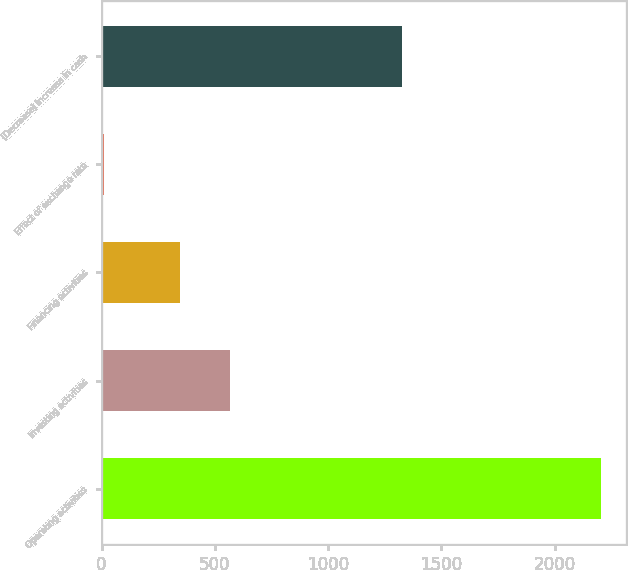Convert chart to OTSL. <chart><loc_0><loc_0><loc_500><loc_500><bar_chart><fcel>Operating activities<fcel>Investing activities<fcel>Financing activities<fcel>Effect of exchange rate<fcel>(Decrease) increase in cash<nl><fcel>2206<fcel>567.6<fcel>348<fcel>10<fcel>1328<nl></chart> 